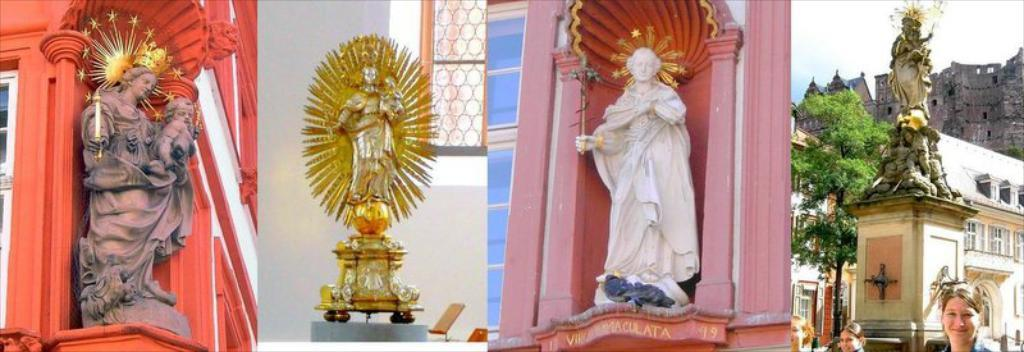What type of artwork is depicted in the image? The image is a collage. What can be found within the collage? The collage contains different statues. What is the reaction of the eggnog to the statues in the collage? There is no eggnog present in the image, so it cannot have a reaction to the statues. 